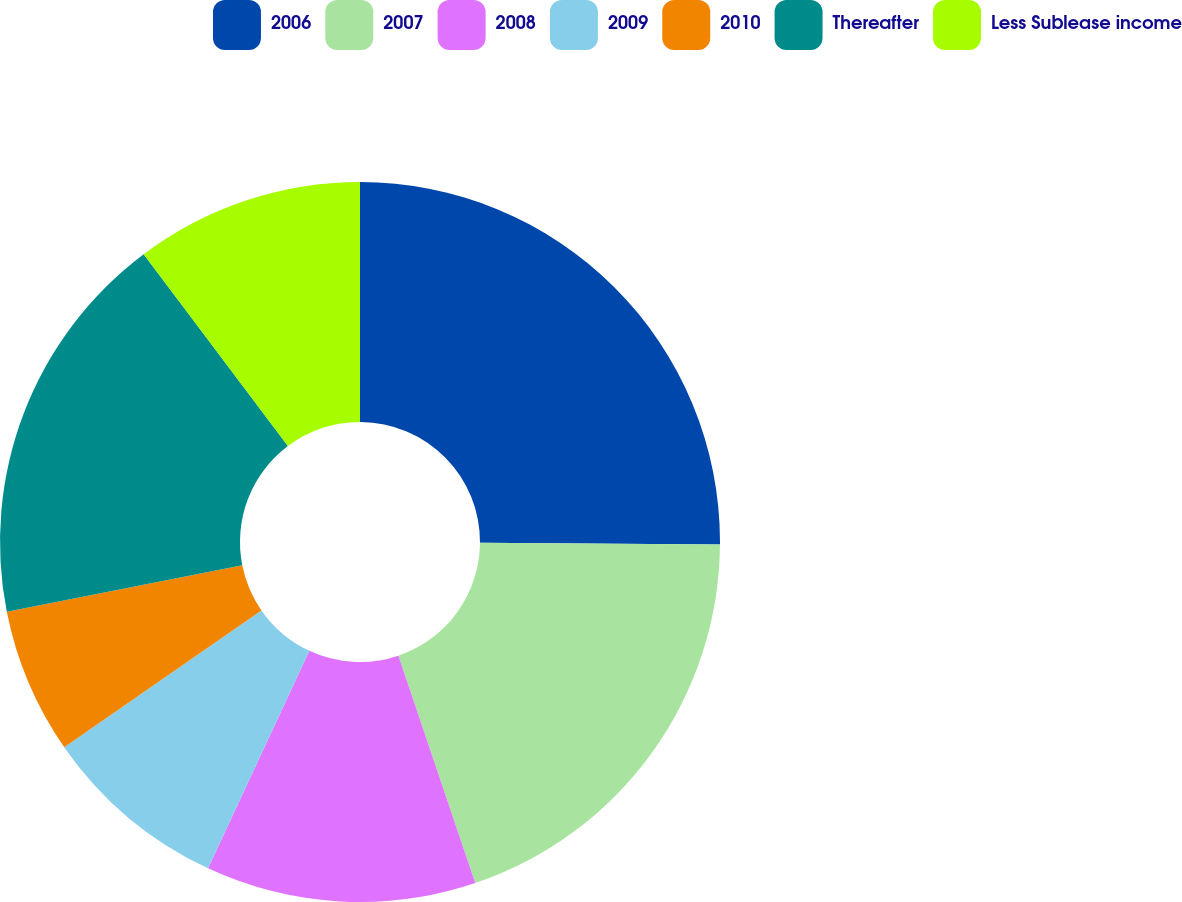<chart> <loc_0><loc_0><loc_500><loc_500><pie_chart><fcel>2006<fcel>2007<fcel>2008<fcel>2009<fcel>2010<fcel>Thereafter<fcel>Less Sublease income<nl><fcel>25.11%<fcel>19.7%<fcel>12.12%<fcel>8.41%<fcel>6.55%<fcel>17.84%<fcel>10.26%<nl></chart> 